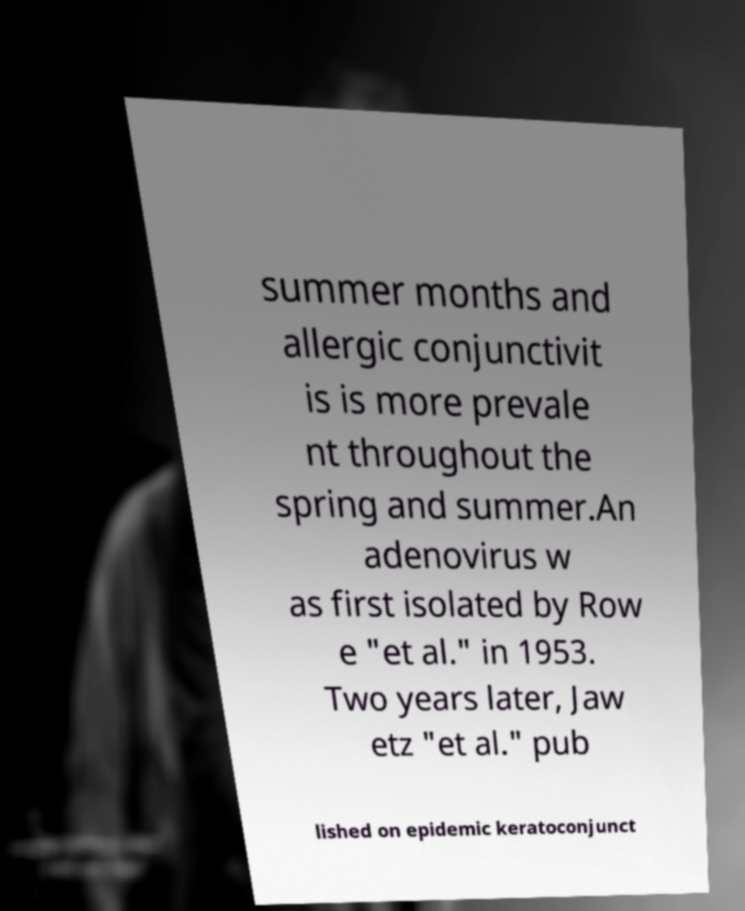Could you assist in decoding the text presented in this image and type it out clearly? summer months and allergic conjunctivit is is more prevale nt throughout the spring and summer.An adenovirus w as first isolated by Row e "et al." in 1953. Two years later, Jaw etz "et al." pub lished on epidemic keratoconjunct 